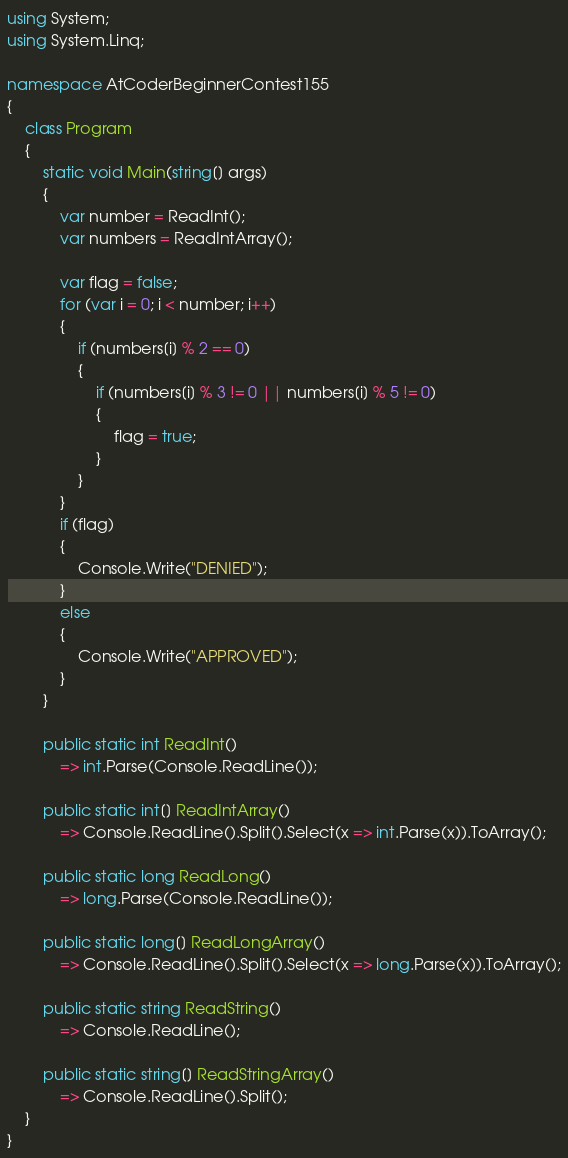<code> <loc_0><loc_0><loc_500><loc_500><_C#_>using System;
using System.Linq;

namespace AtCoderBeginnerContest155
{
	class Program
	{
		static void Main(string[] args)
		{
			var number = ReadInt();
			var numbers = ReadIntArray();

			var flag = false;
			for (var i = 0; i < number; i++)
			{
				if (numbers[i] % 2 == 0)
				{
					if (numbers[i] % 3 != 0 || numbers[i] % 5 != 0)
					{
						flag = true;
					}
				}
			}
			if (flag)
			{
				Console.Write("DENIED");
			}
			else
			{
				Console.Write("APPROVED");
			}
		}

		public static int ReadInt()
			=> int.Parse(Console.ReadLine());

		public static int[] ReadIntArray()
			=> Console.ReadLine().Split().Select(x => int.Parse(x)).ToArray();

		public static long ReadLong()
			=> long.Parse(Console.ReadLine());

		public static long[] ReadLongArray()
			=> Console.ReadLine().Split().Select(x => long.Parse(x)).ToArray();

		public static string ReadString()
			=> Console.ReadLine();

		public static string[] ReadStringArray()
			=> Console.ReadLine().Split();
	}
}
</code> 